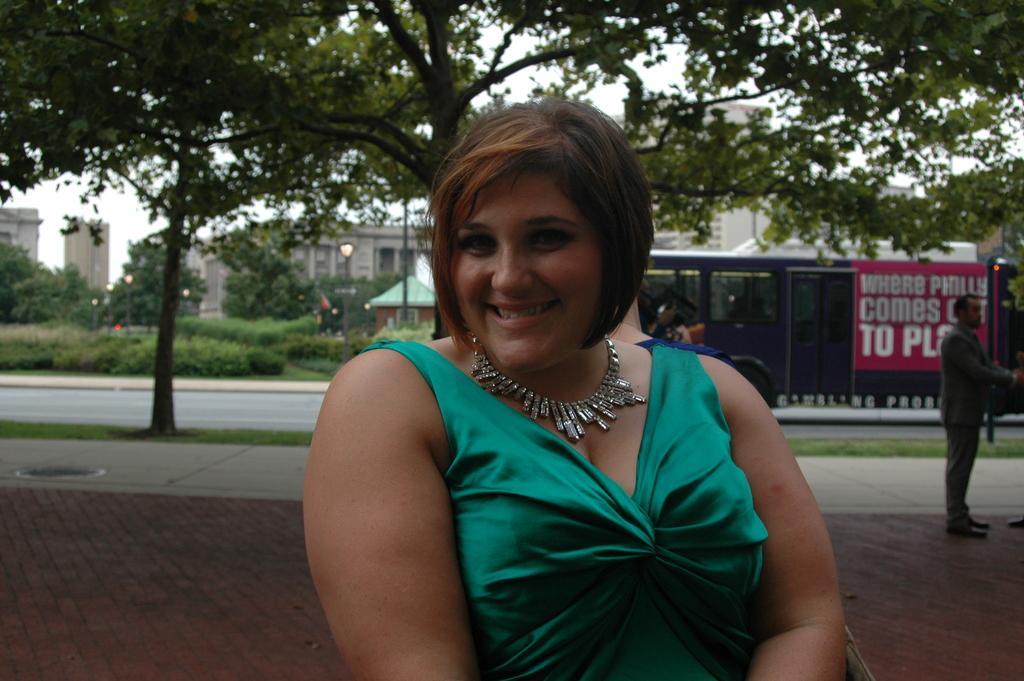In one or two sentences, can you explain what this image depicts? In the center of the image there is a woman standing on the road. In the background we can see trees, plants, vehicles, road, person's, buildings and sky. 